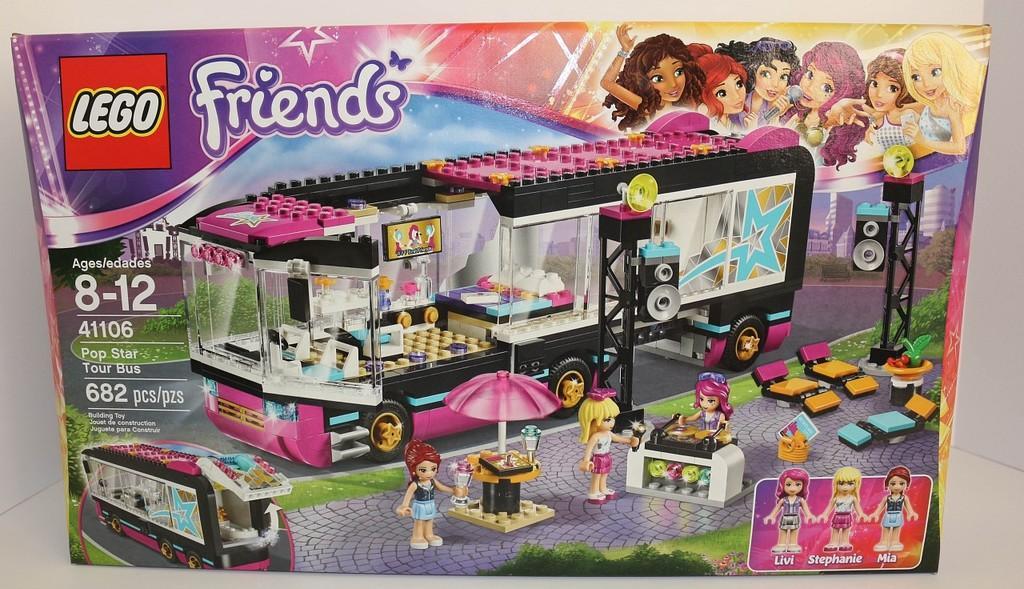How would you summarize this image in a sentence or two? In this picture I can see a poster in front on which there are words written and I see the barbie dolls set. 